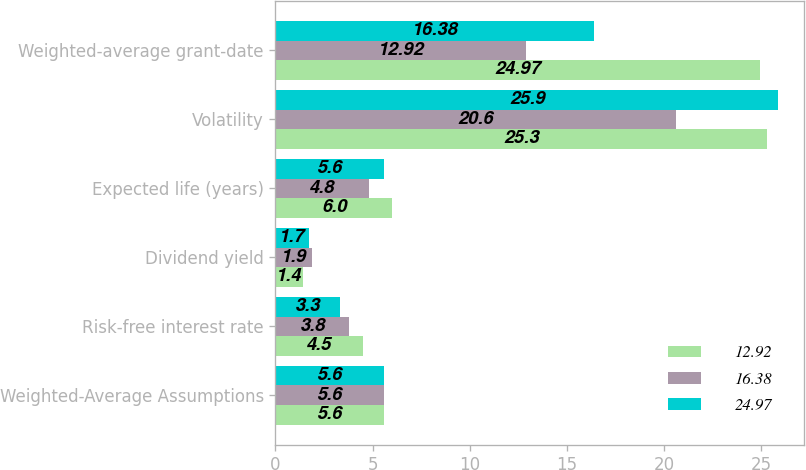<chart> <loc_0><loc_0><loc_500><loc_500><stacked_bar_chart><ecel><fcel>Weighted-Average Assumptions<fcel>Risk-free interest rate<fcel>Dividend yield<fcel>Expected life (years)<fcel>Volatility<fcel>Weighted-average grant-date<nl><fcel>12.92<fcel>5.6<fcel>4.5<fcel>1.4<fcel>6<fcel>25.3<fcel>24.97<nl><fcel>16.38<fcel>5.6<fcel>3.8<fcel>1.9<fcel>4.8<fcel>20.6<fcel>12.92<nl><fcel>24.97<fcel>5.6<fcel>3.3<fcel>1.7<fcel>5.6<fcel>25.9<fcel>16.38<nl></chart> 